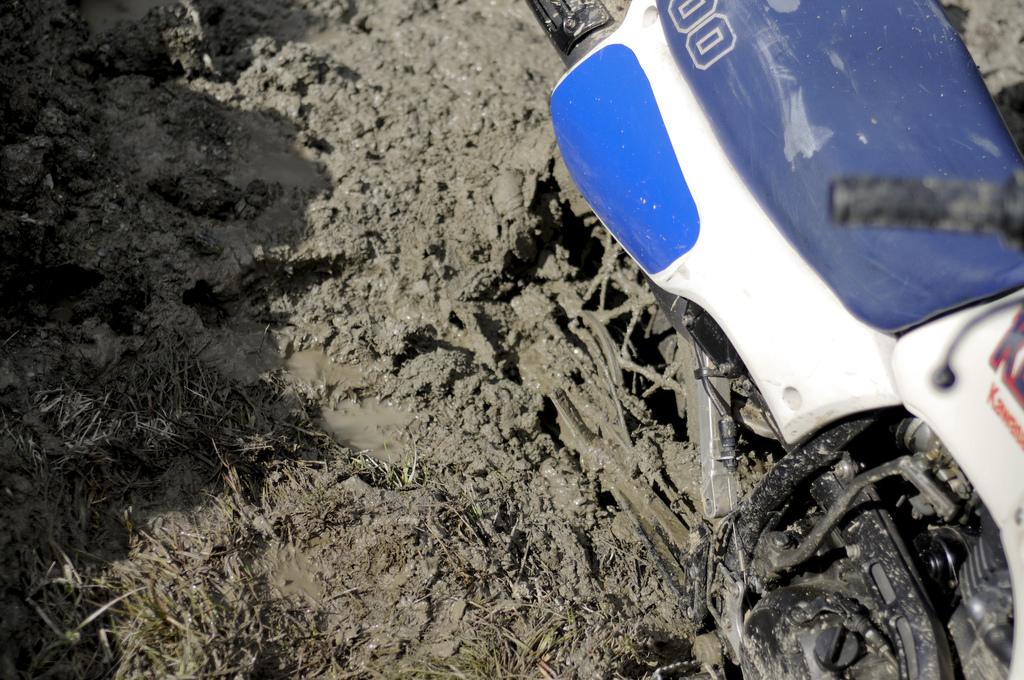What is the main subject in the image? There is a thing in the image. Can you describe the surface on which the thing is placed? The thing is on a mud floor. What direction is the thing facing in the image? The provided facts do not mention the direction the thing is facing, so we cannot determine that information. Is the thing made of bricks in the image? The provided facts do not mention the material of the thing, so we cannot determine if it is made of bricks. Does the image show a property with the thing on the mud floor? The provided facts do not mention the concept of "property," so we cannot determine if the image shows a property. 